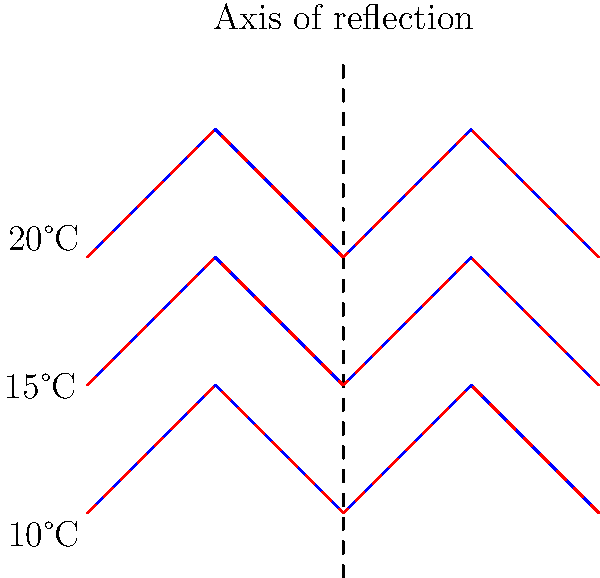The graph shows temperature contour lines (blue) for a coastal region, with an axis of reflection (dashed line) at 2 km from the coast. The red dashed lines represent the reflected contours. If the temperature at point (1,1) is 15°C, what is the temperature at point (3,1)? To solve this problem, we need to understand the concept of reflection in transformational geometry and how it applies to temperature contour lines. Let's break it down step-by-step:

1. Identify the given information:
   - The axis of reflection is at x = 2 km from the coast.
   - The original contours are in blue, and the reflected contours are in red.
   - The temperature at point (1,1) is 15°C.

2. Understand the reflection principle:
   - In a reflection, each point is mapped to a point that is equidistant from the axis of reflection on the opposite side.
   - The shape and size of the object remain unchanged after reflection.

3. Locate the point (1,1) and its reflection:
   - Point (1,1) is on the original (blue) contour line.
   - Its reflection will be equidistant from the axis of reflection (x = 2) on the opposite side.
   - The reflected point of (1,1) is (3,1).

4. Apply the properties of reflection to temperature contours:
   - In climate patterns, symmetrical reflections often indicate similar temperature patterns on both sides of the axis.
   - This means that the temperature at a point and its reflected point should be the same.

5. Conclude the temperature at (3,1):
   - Since (3,1) is the reflection of (1,1), and the temperature at (1,1) is 15°C,
   - The temperature at (3,1) must also be 15°C.

This symmetry in temperature patterns is often observed in coastal regions due to similar geographical features and climate influences on both sides of a central axis.
Answer: 15°C 